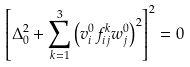Convert formula to latex. <formula><loc_0><loc_0><loc_500><loc_500>\left [ \Delta _ { 0 } ^ { 2 } + \sum _ { k = 1 } ^ { 3 } \left ( v _ { i } ^ { 0 } f _ { i j } ^ { k } w _ { j } ^ { 0 } \right ) ^ { 2 } \right ] ^ { 2 } = 0</formula> 